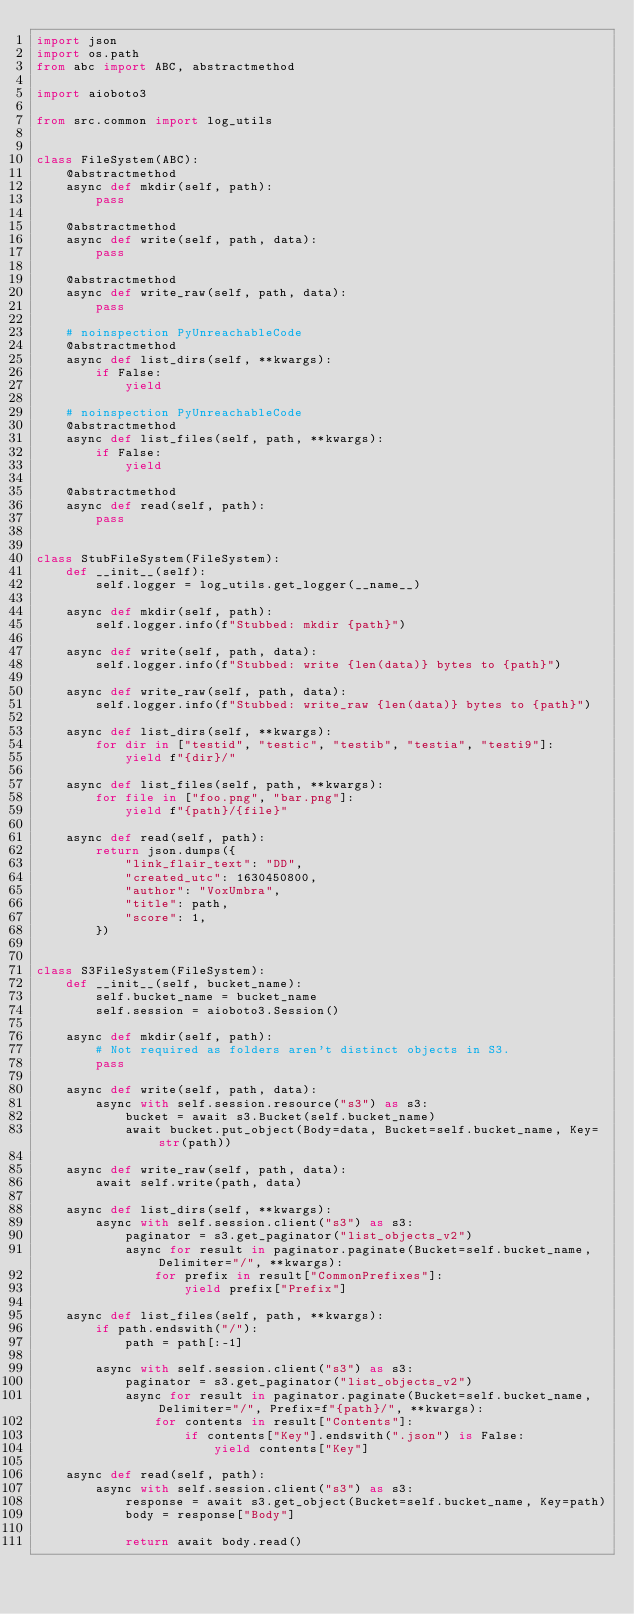<code> <loc_0><loc_0><loc_500><loc_500><_Python_>import json
import os.path
from abc import ABC, abstractmethod

import aioboto3

from src.common import log_utils


class FileSystem(ABC):
    @abstractmethod
    async def mkdir(self, path):
        pass

    @abstractmethod
    async def write(self, path, data):
        pass

    @abstractmethod
    async def write_raw(self, path, data):
        pass

    # noinspection PyUnreachableCode
    @abstractmethod
    async def list_dirs(self, **kwargs):
        if False:
            yield

    # noinspection PyUnreachableCode
    @abstractmethod
    async def list_files(self, path, **kwargs):
        if False:
            yield

    @abstractmethod
    async def read(self, path):
        pass


class StubFileSystem(FileSystem):
    def __init__(self):
        self.logger = log_utils.get_logger(__name__)

    async def mkdir(self, path):
        self.logger.info(f"Stubbed: mkdir {path}")

    async def write(self, path, data):
        self.logger.info(f"Stubbed: write {len(data)} bytes to {path}")

    async def write_raw(self, path, data):
        self.logger.info(f"Stubbed: write_raw {len(data)} bytes to {path}")

    async def list_dirs(self, **kwargs):
        for dir in ["testid", "testic", "testib", "testia", "testi9"]:
            yield f"{dir}/"

    async def list_files(self, path, **kwargs):
        for file in ["foo.png", "bar.png"]:
            yield f"{path}/{file}"

    async def read(self, path):
        return json.dumps({
            "link_flair_text": "DD",
            "created_utc": 1630450800,
            "author": "VoxUmbra",
            "title": path,
            "score": 1,
        })


class S3FileSystem(FileSystem):
    def __init__(self, bucket_name):
        self.bucket_name = bucket_name
        self.session = aioboto3.Session()

    async def mkdir(self, path):
        # Not required as folders aren't distinct objects in S3.
        pass

    async def write(self, path, data):
        async with self.session.resource("s3") as s3:
            bucket = await s3.Bucket(self.bucket_name)
            await bucket.put_object(Body=data, Bucket=self.bucket_name, Key=str(path))

    async def write_raw(self, path, data):
        await self.write(path, data)

    async def list_dirs(self, **kwargs):
        async with self.session.client("s3") as s3:
            paginator = s3.get_paginator("list_objects_v2")
            async for result in paginator.paginate(Bucket=self.bucket_name, Delimiter="/", **kwargs):
                for prefix in result["CommonPrefixes"]:
                    yield prefix["Prefix"]

    async def list_files(self, path, **kwargs):
        if path.endswith("/"):
            path = path[:-1]

        async with self.session.client("s3") as s3:
            paginator = s3.get_paginator("list_objects_v2")
            async for result in paginator.paginate(Bucket=self.bucket_name, Delimiter="/", Prefix=f"{path}/", **kwargs):
                for contents in result["Contents"]:
                    if contents["Key"].endswith(".json") is False:
                        yield contents["Key"]

    async def read(self, path):
        async with self.session.client("s3") as s3:
            response = await s3.get_object(Bucket=self.bucket_name, Key=path)
            body = response["Body"]

            return await body.read()
</code> 